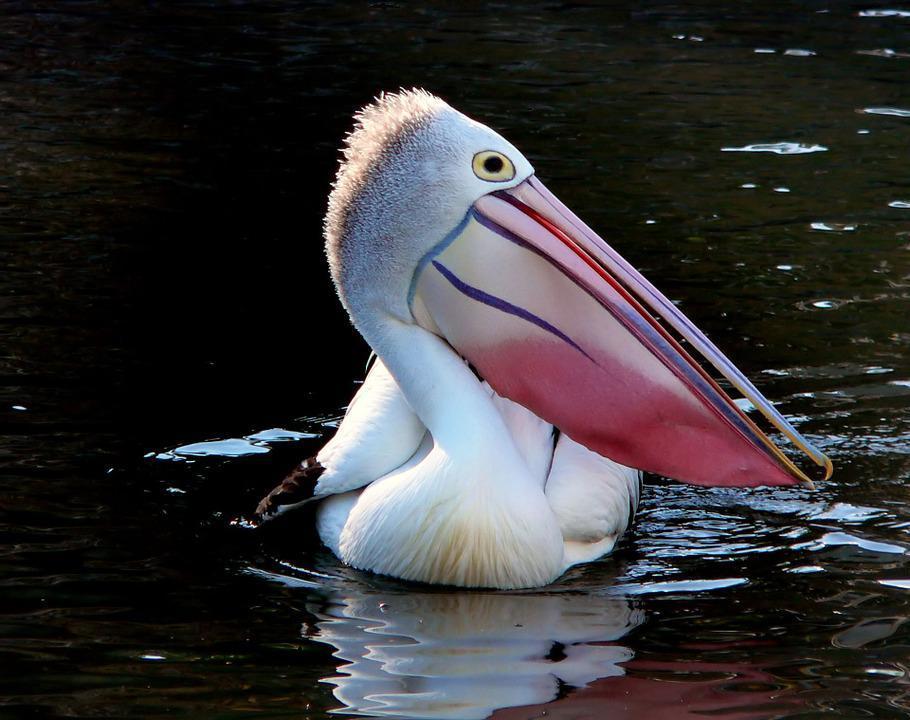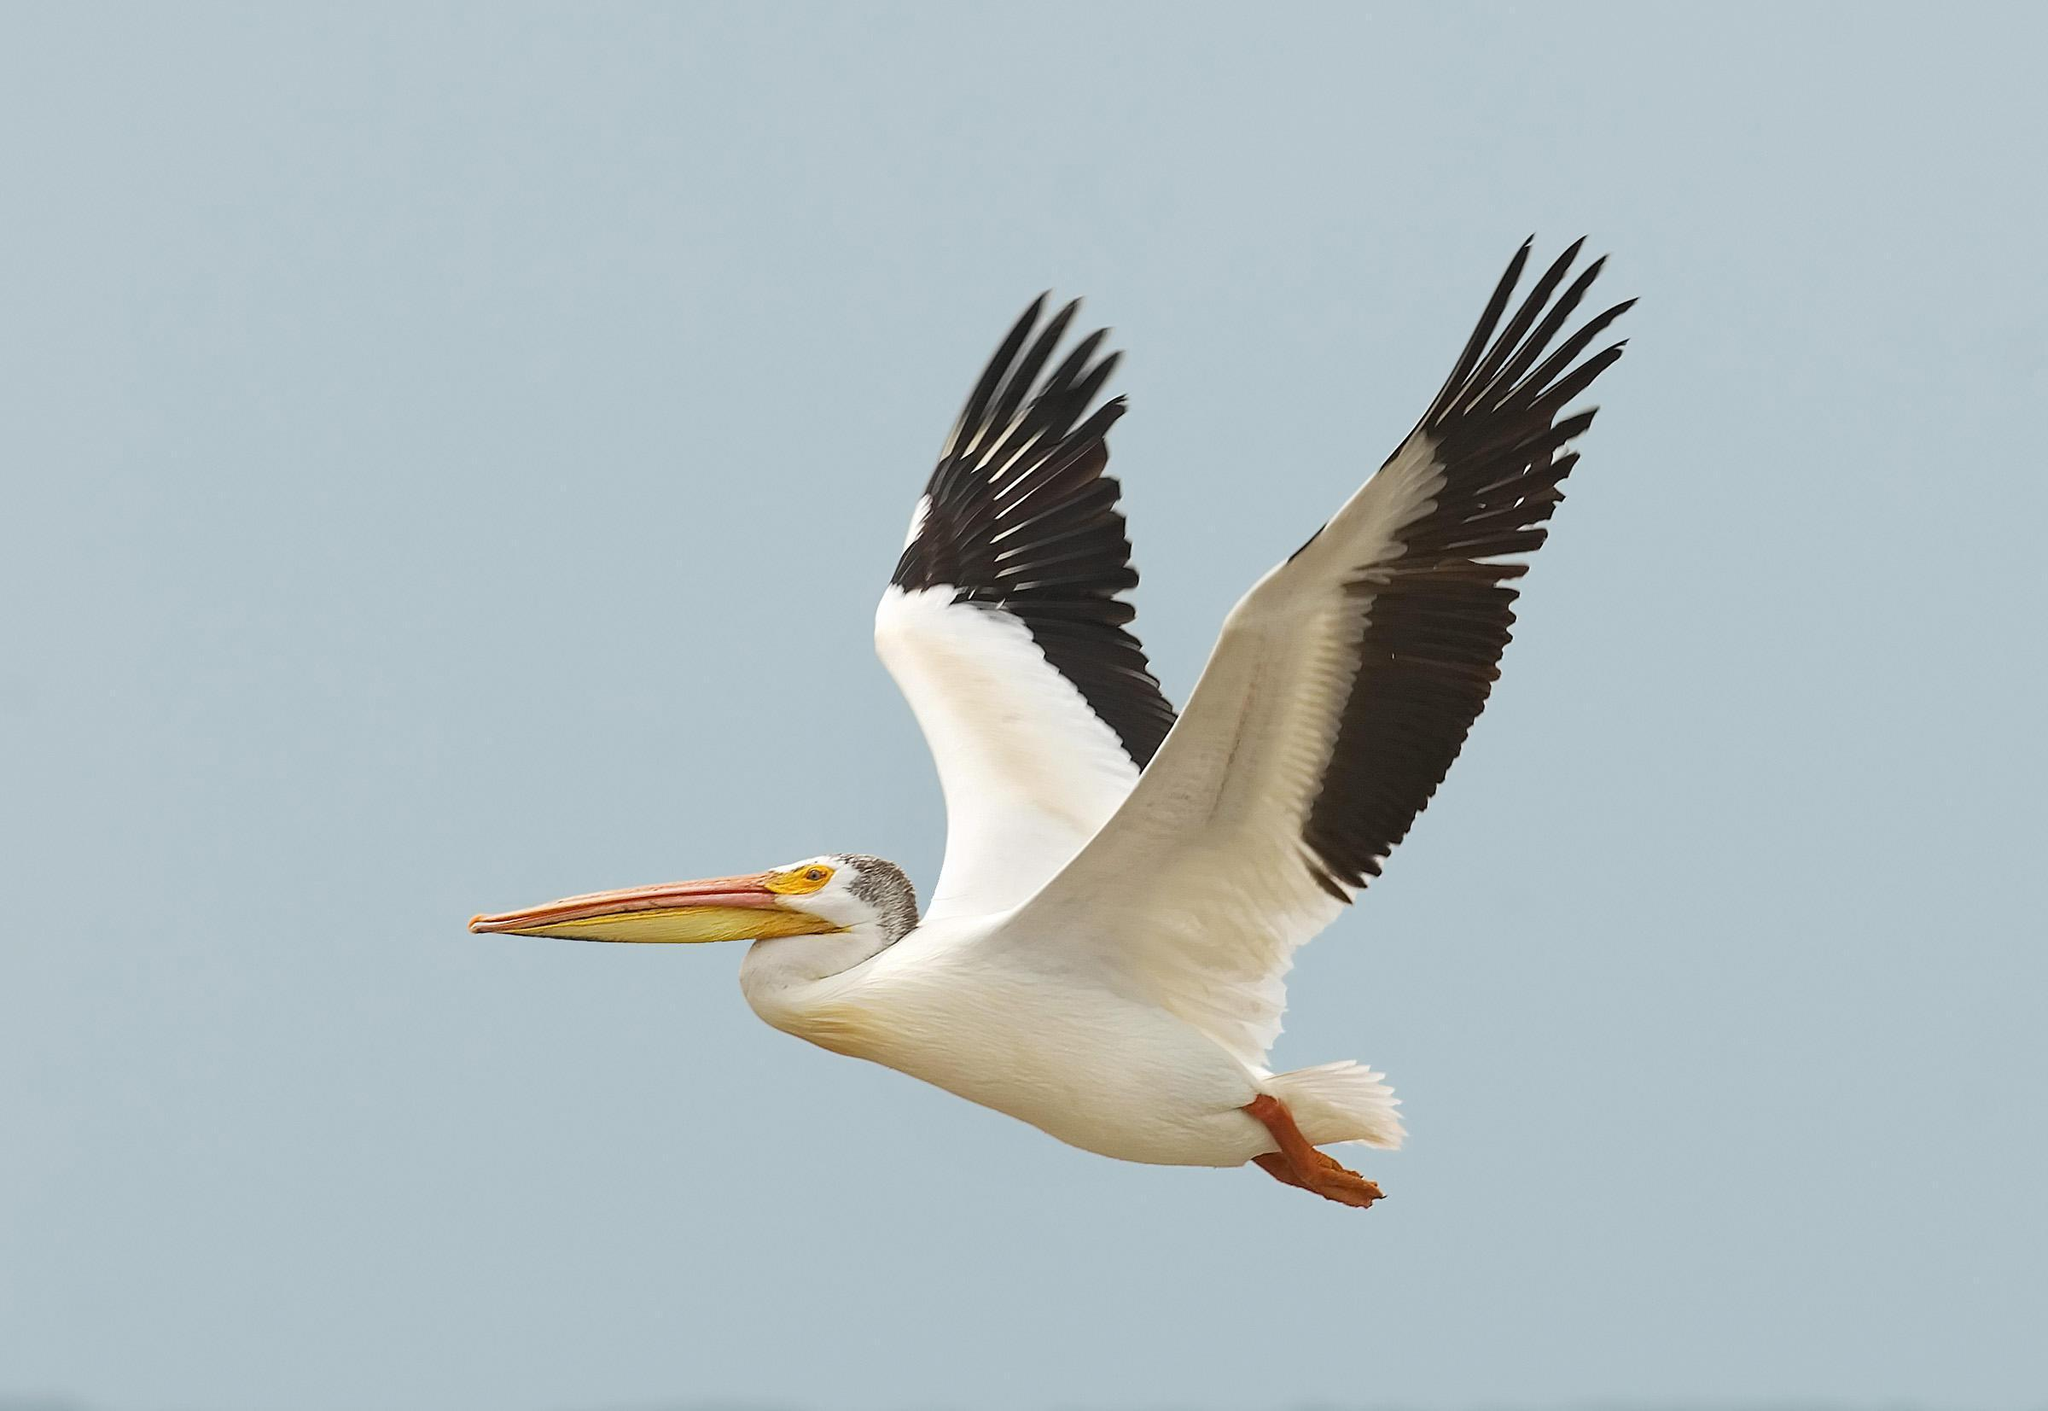The first image is the image on the left, the second image is the image on the right. For the images displayed, is the sentence "The bird in the left image is facing towards the left." factually correct? Answer yes or no. No. 